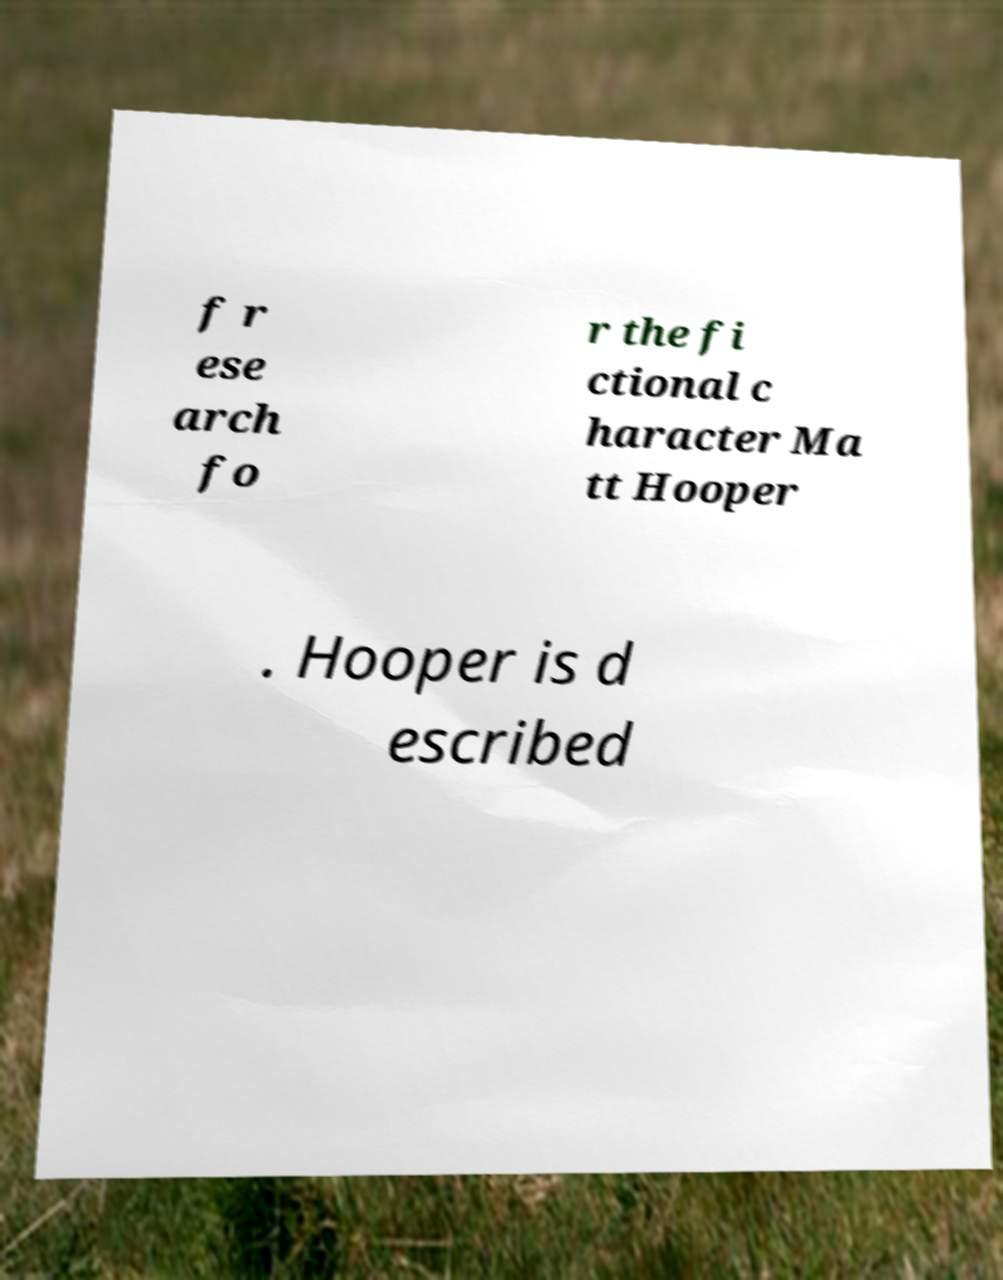For documentation purposes, I need the text within this image transcribed. Could you provide that? f r ese arch fo r the fi ctional c haracter Ma tt Hooper . Hooper is d escribed 